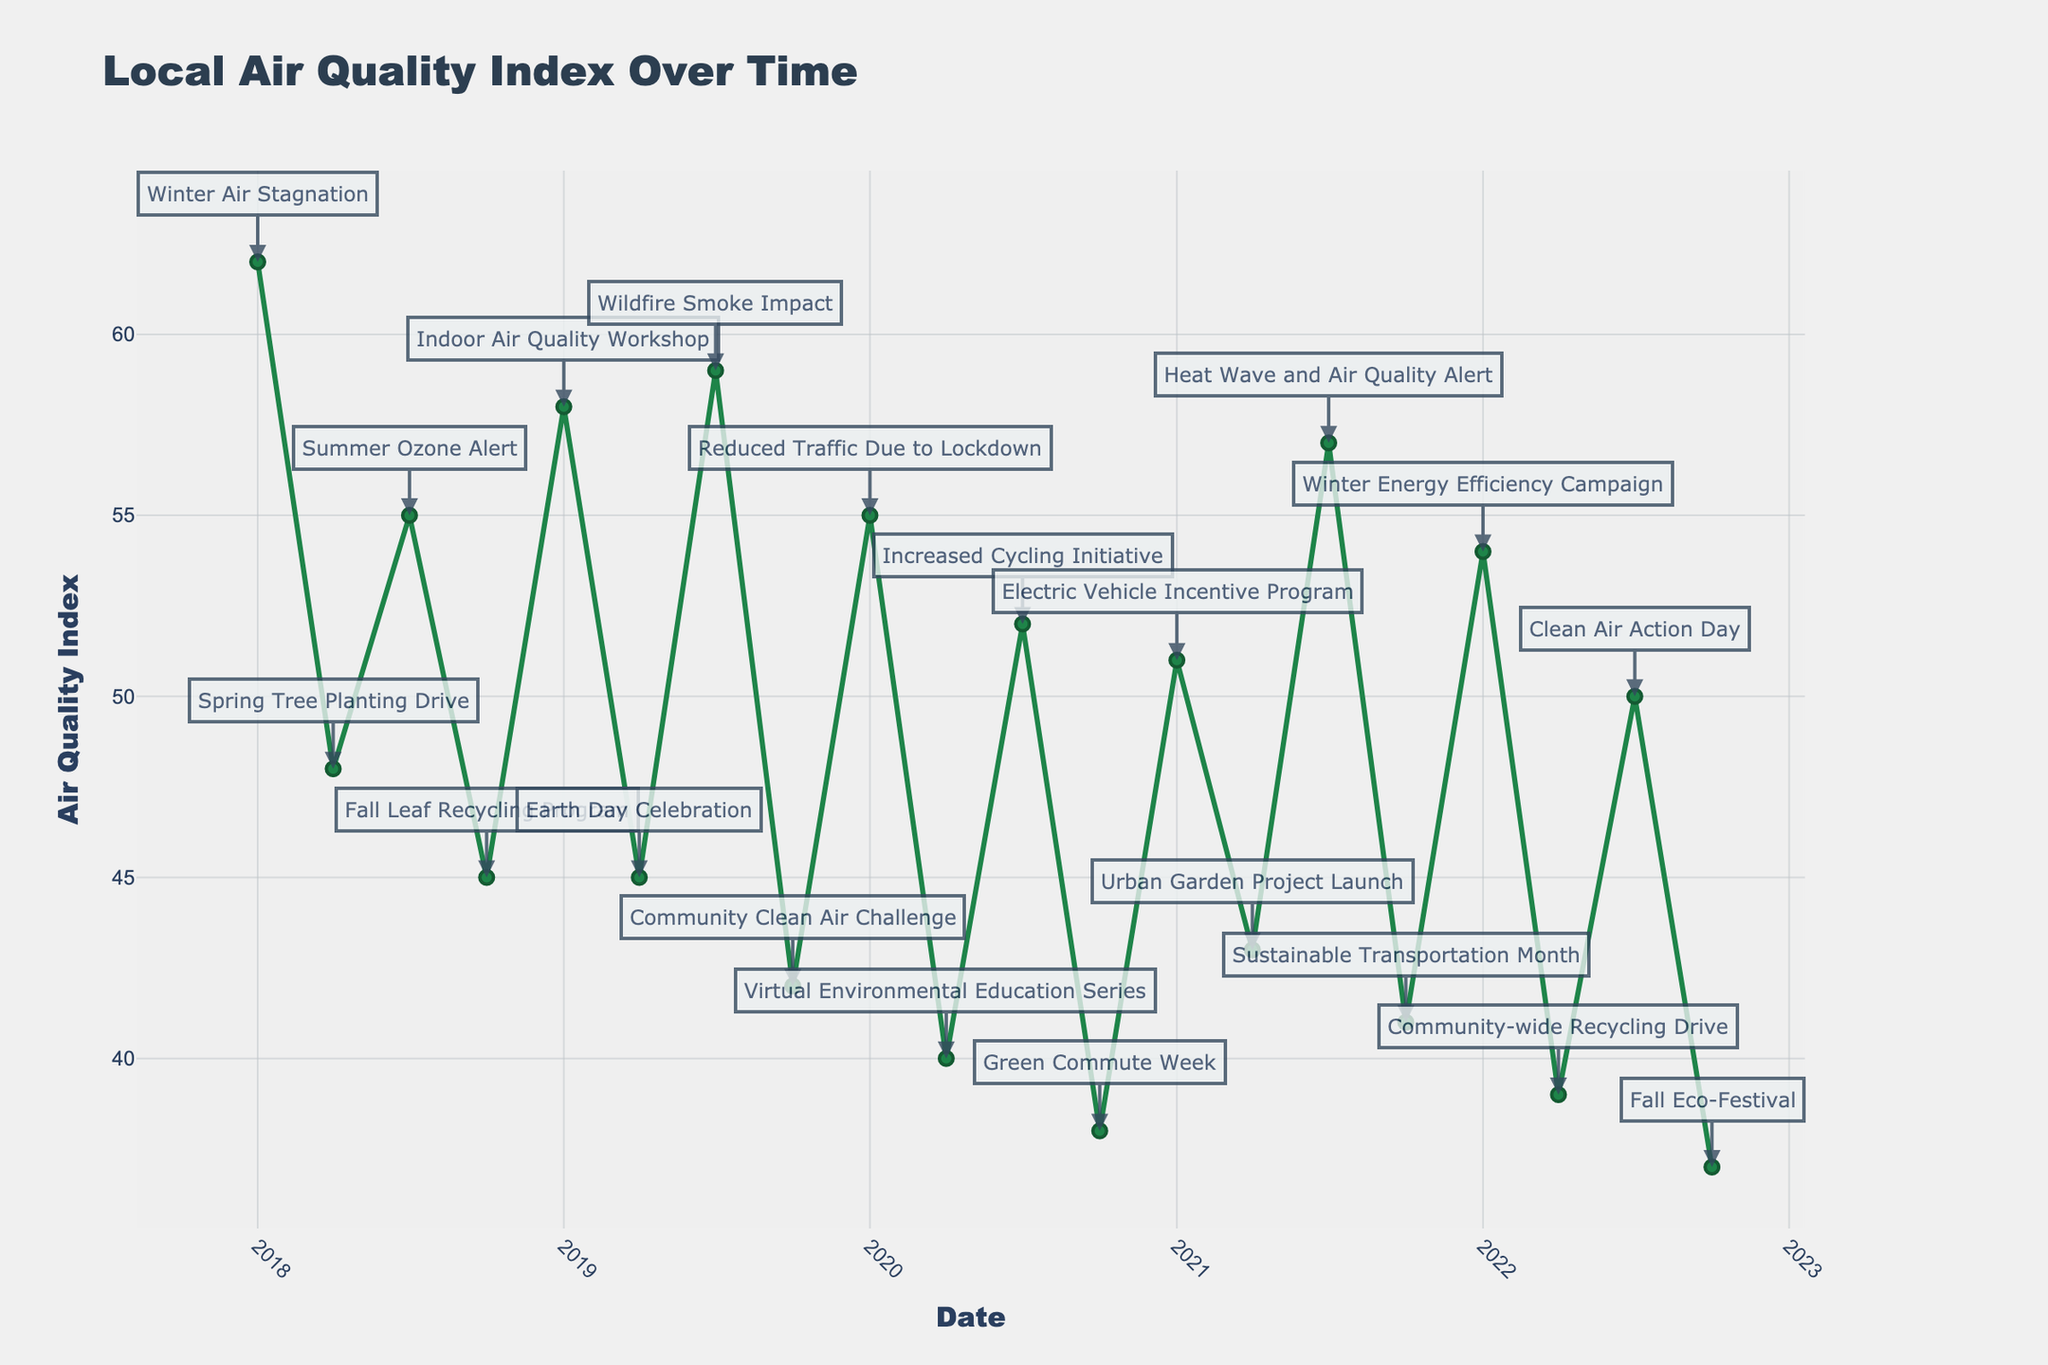What's the general trend in the Air Quality Index from 2018 to 2022? From 2018 to 2022, the Air Quality Index generally shows a decreasing trend, evidenced by the overall decline in AQI values over the years, especially noticeable by comparing the start (around 62) and end values (around 37).
Answer: Decreasing How did the Air Quality Index change during the winter seasons over the years? By examining the points corresponding to January each year, the AQI starts at 62 in January 2018 and decreases to 54 by January 2022, highlighting an overall improvement in winter air quality over the years.
Answer: Improved Which year had the lowest average Air Quality Index? By visually comparing the AQI values across all months for each year, 2022 consistently shows lower AQI values compared to other years, making it the year with the lowest average AQI.
Answer: 2022 What impact did the "Wildfire Smoke Impact" event have compared to the surrounding periods? Comparing the AQI around July 2019 (Wildfire Smoke Impact) to the surrounding periods, there is a noticeable increase in AQI to 59, indicating poorer air quality during the event compared to the months before and after.
Answer: Increased AQI Which month and year recorded the highest Air Quality Index? By examining the peaks in the line chart, January 2018 recorded the highest AQI of 62.
Answer: January 2018 How does the Air Quality Index typically change from winter to spring each year? Observing the points from January to April each year, the AQI typically shows a decrease from winter to spring, reflecting improved air quality as the seasons change from winter to spring.
Answer: Decreases What was the effect of the "Reduced Traffic Due to Lockdown" event on the Air Quality Index? The "Reduced Traffic Due to Lockdown" event in January 2020 correlates with a noticeable drop in AQI from the previous January, indicating an improvement in air quality.
Answer: Decreased AQI Compare the Air Quality Index in July 2020 to July 2019. The AQI in July 2020 (52) is lower than that in July 2019 (59), indicating better air quality in 2020 compared to 2019.
Answer: Lower in July 2020 What is the difference in Air Quality Index between the highest and lowest recorded values? The highest recorded AQI is 62 (January 2018), and the lowest is 37 (October 2022). The difference is 62 - 37 = 25.
Answer: 25 How does the AQI in 2021 compare to the AQI in 2022 during April? In April, the AQI for 2021 is 43 and for 2022 is 39, meaning that the air quality improved (lower AQI) in April 2022 compared to April 2021.
Answer: Improved in 2022 